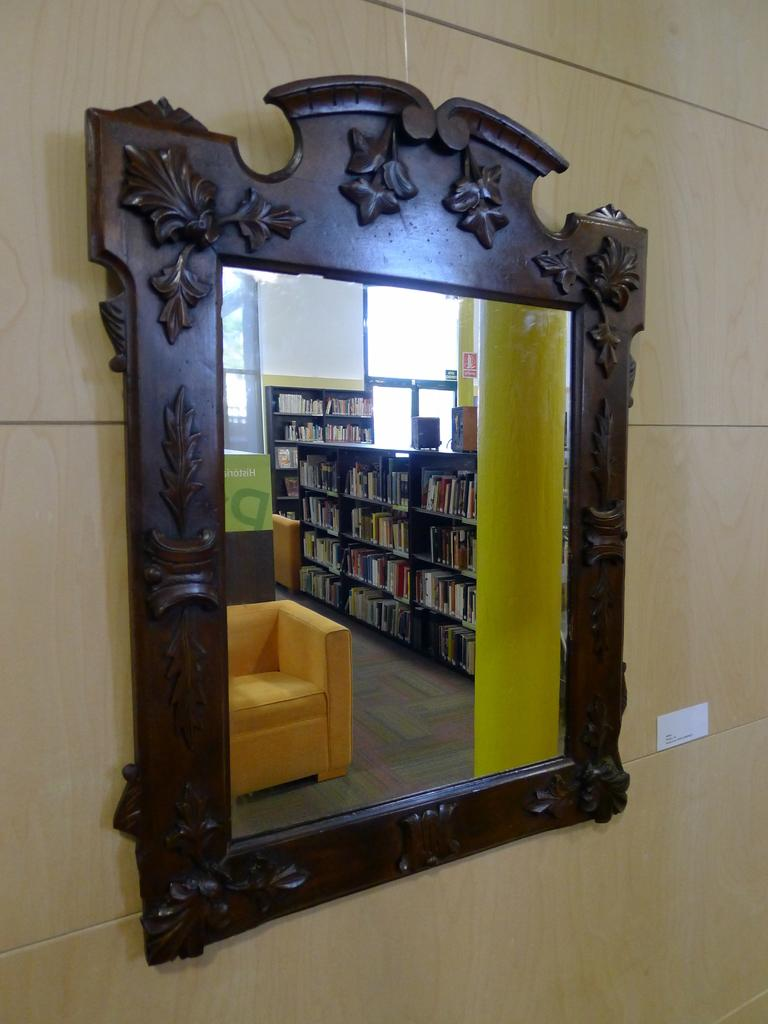What object is placed on the ground in the image? There is a mirror on the ground in the image. What type of furniture can be seen in the background of the image? There is a sofa in the background of the image. What items are stored in the racks in the background of the image? There are books placed in racks in the background of the image. What type of audio equipment is present in the background of the image? There are speakers in the background of the image. What architectural feature allows natural light to enter the room in the image? There are windows in the background of the image. What type of knife is being used to blow wax off the mirror in the image? There is no knife or wax present in the image; it only features a mirror on the ground and various items in the background. 